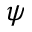Convert formula to latex. <formula><loc_0><loc_0><loc_500><loc_500>\psi</formula> 